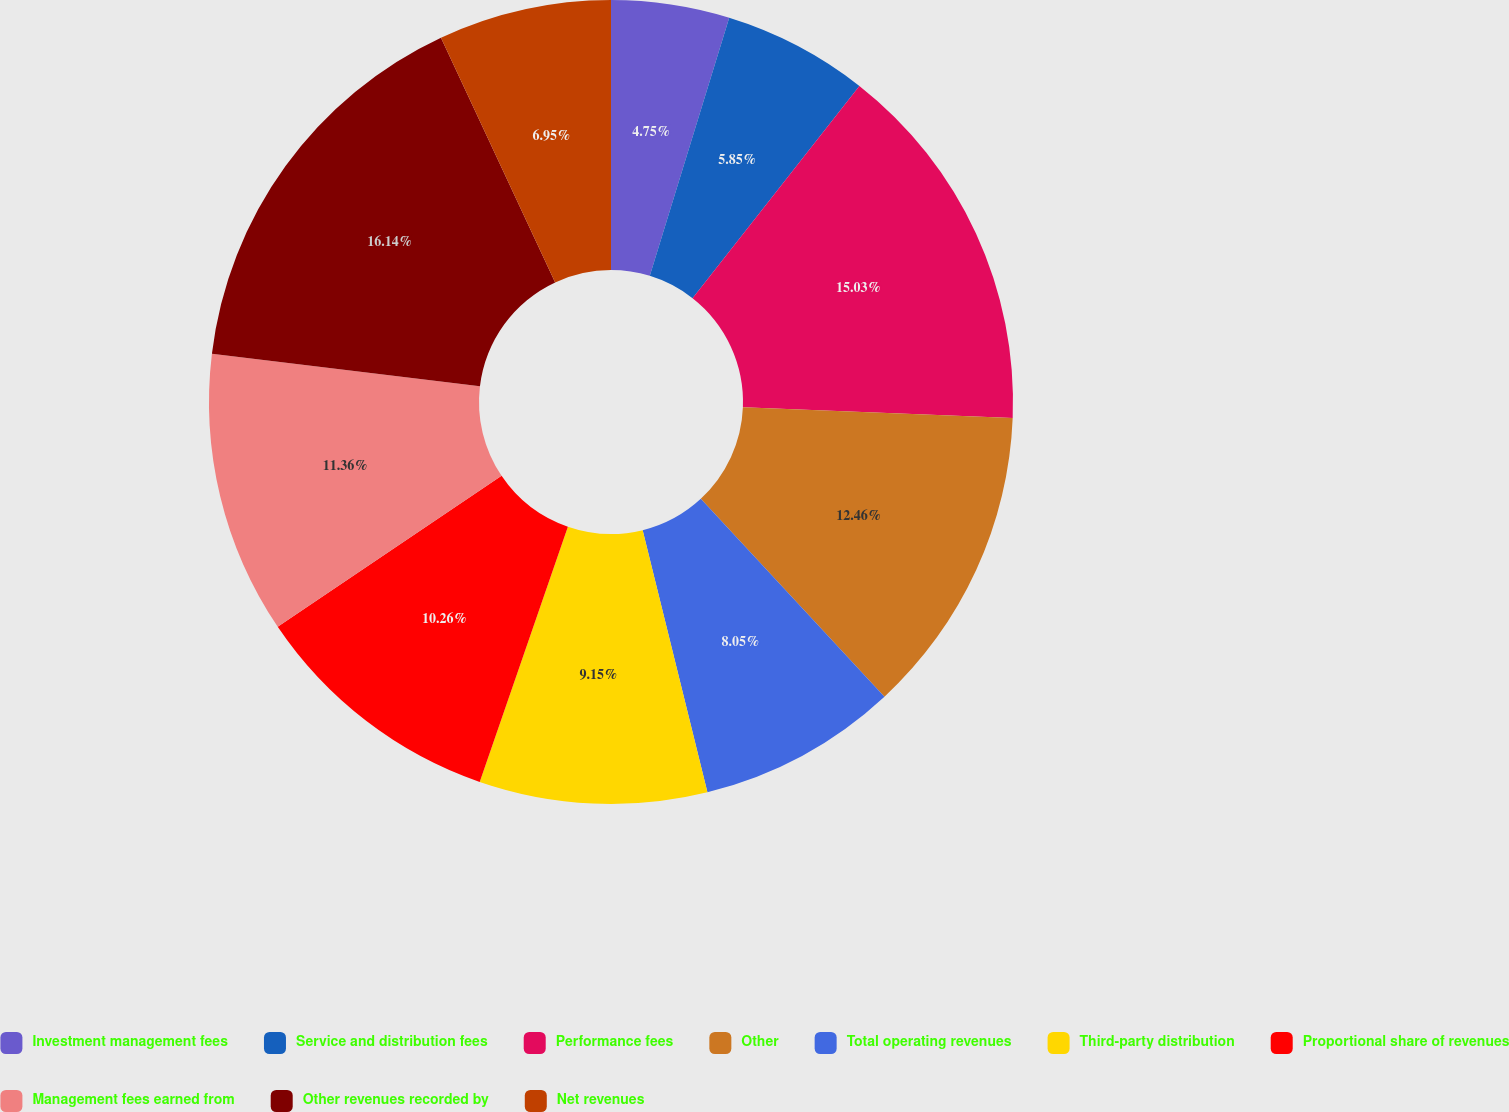Convert chart to OTSL. <chart><loc_0><loc_0><loc_500><loc_500><pie_chart><fcel>Investment management fees<fcel>Service and distribution fees<fcel>Performance fees<fcel>Other<fcel>Total operating revenues<fcel>Third-party distribution<fcel>Proportional share of revenues<fcel>Management fees earned from<fcel>Other revenues recorded by<fcel>Net revenues<nl><fcel>4.75%<fcel>5.85%<fcel>15.03%<fcel>12.46%<fcel>8.05%<fcel>9.15%<fcel>10.26%<fcel>11.36%<fcel>16.13%<fcel>6.95%<nl></chart> 